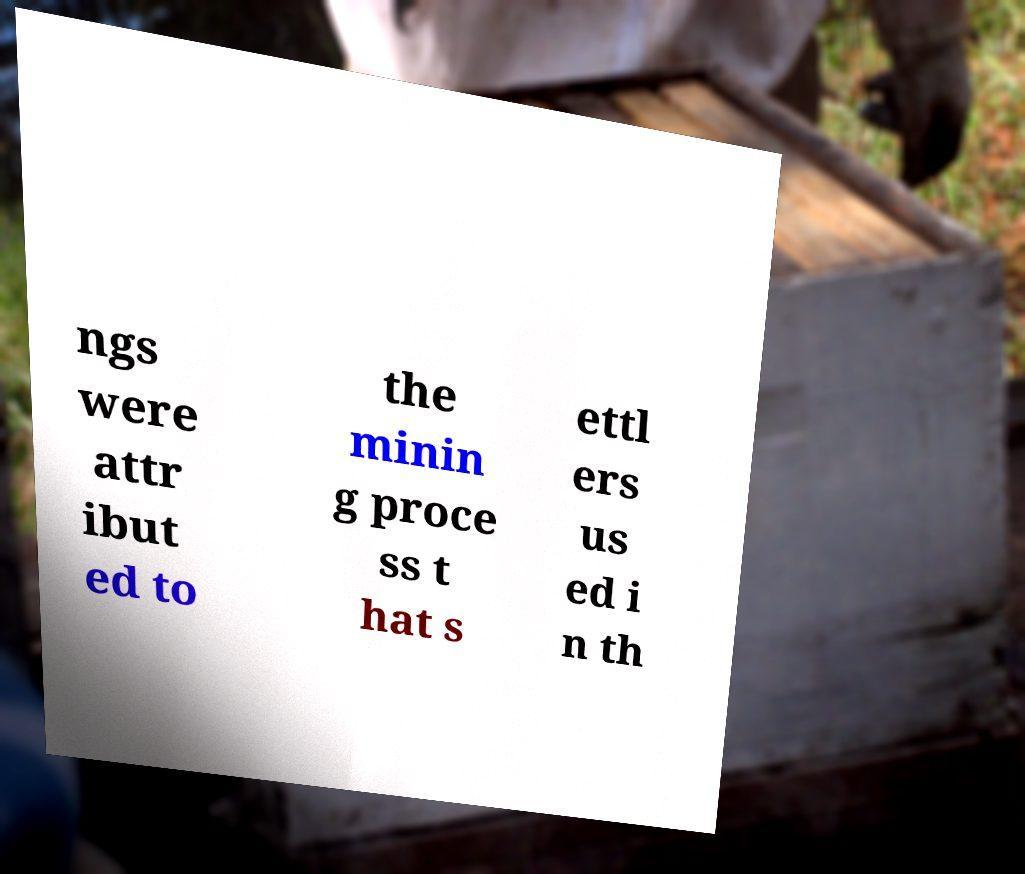For documentation purposes, I need the text within this image transcribed. Could you provide that? ngs were attr ibut ed to the minin g proce ss t hat s ettl ers us ed i n th 